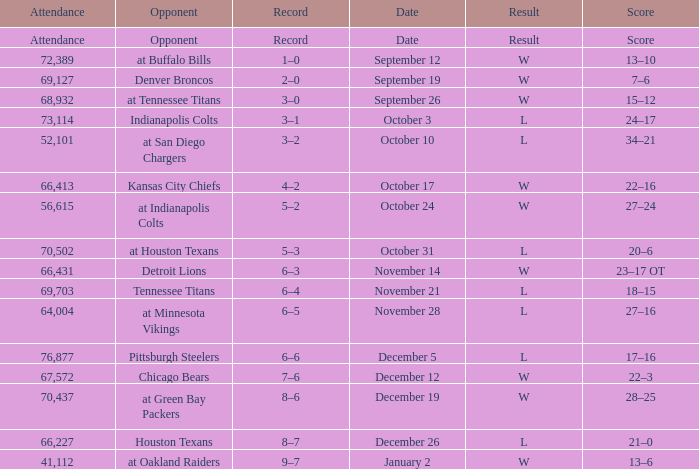What record has w as the result, with January 2 as the date? 9–7. 